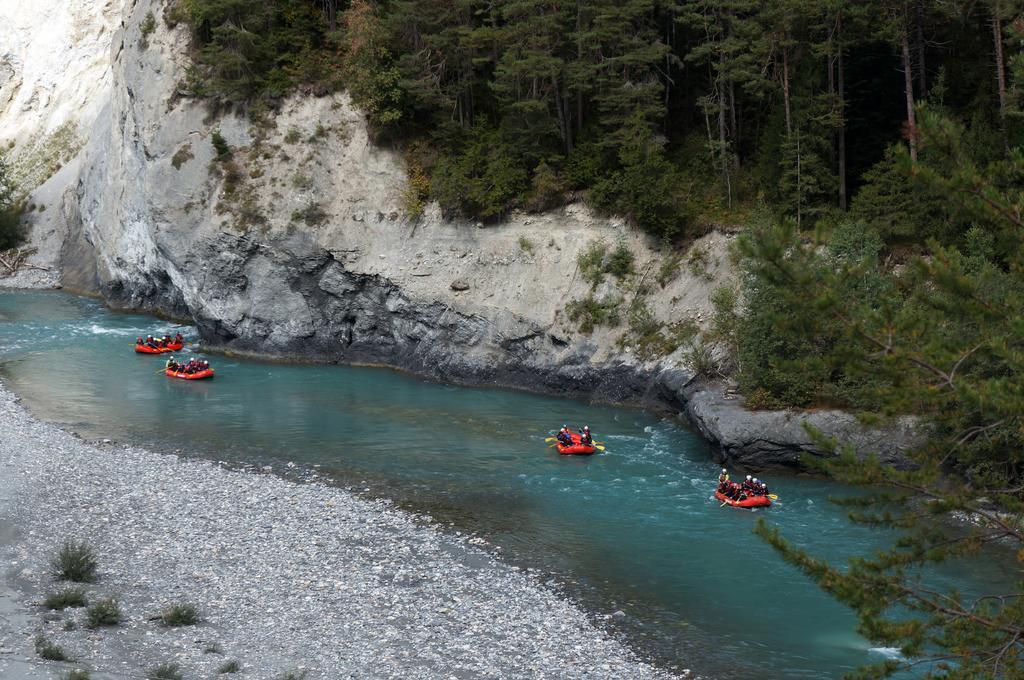Can you describe this image briefly? In the background we can see the mountains and the thicket. We can see the people, paddles, water, plants and people are sitting in the inflatable boats. 